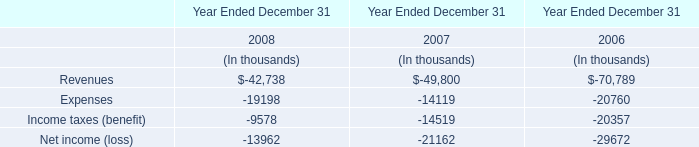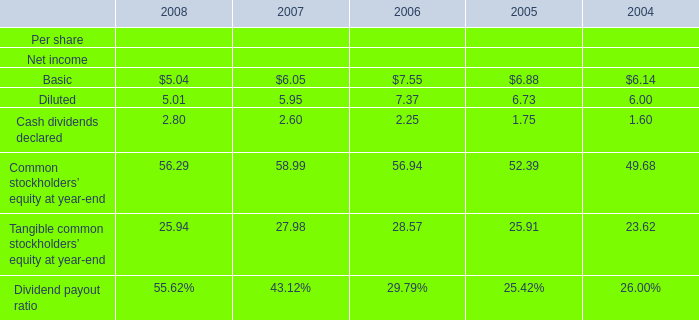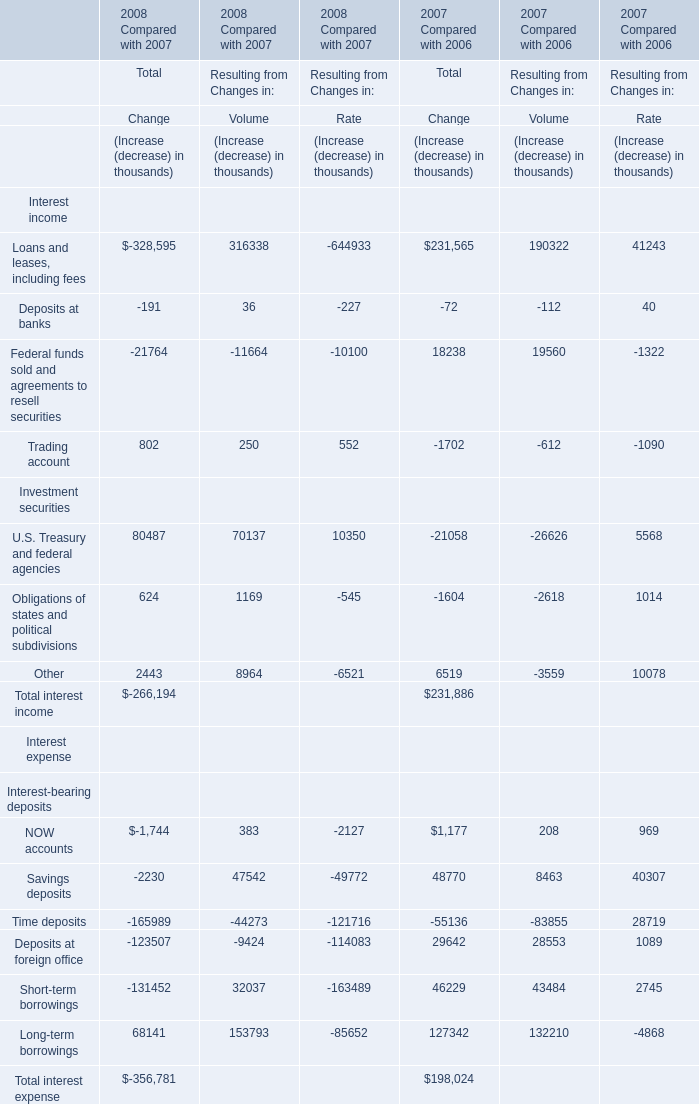What is the growing rate of Cash dividends declared in the year with the most Diluted? 
Computations: ((2.25 - 1.75) / 1.75)
Answer: 0.28571. 